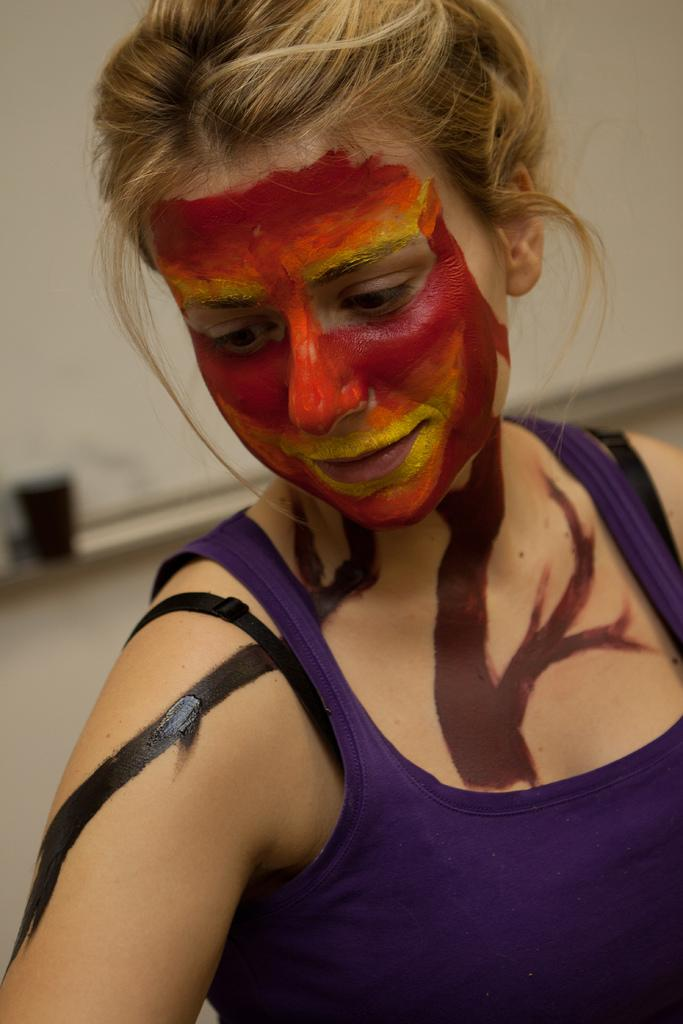What is the main subject of the image? There is a person in the image. Can you describe the person's appearance? The person is wearing clothes. What can be observed about the background of the image? The background of the image is blurred. What type of quill is the person holding in the image? There is no quill present in the image. What flavor of juice is the person drinking in the image? There is no juice present in the image. 